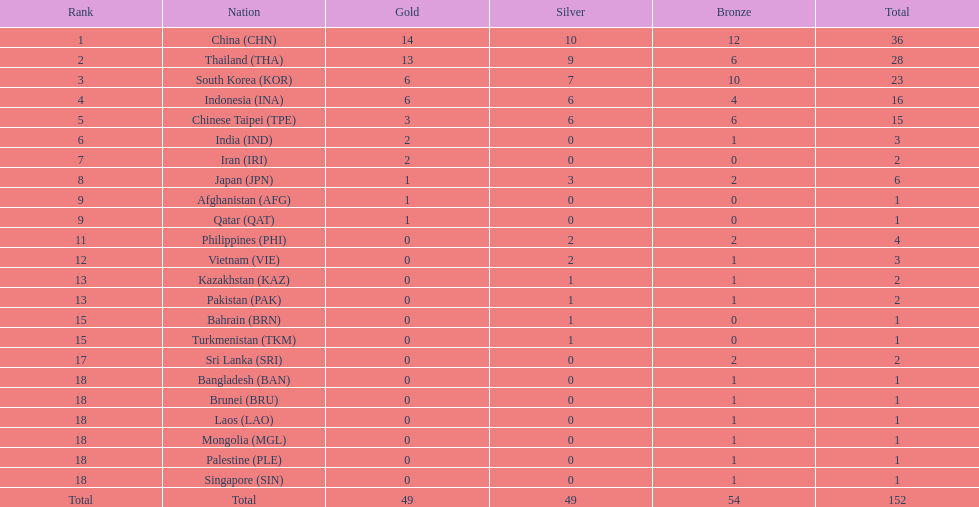Could you help me parse every detail presented in this table? {'header': ['Rank', 'Nation', 'Gold', 'Silver', 'Bronze', 'Total'], 'rows': [['1', 'China\xa0(CHN)', '14', '10', '12', '36'], ['2', 'Thailand\xa0(THA)', '13', '9', '6', '28'], ['3', 'South Korea\xa0(KOR)', '6', '7', '10', '23'], ['4', 'Indonesia\xa0(INA)', '6', '6', '4', '16'], ['5', 'Chinese Taipei\xa0(TPE)', '3', '6', '6', '15'], ['6', 'India\xa0(IND)', '2', '0', '1', '3'], ['7', 'Iran\xa0(IRI)', '2', '0', '0', '2'], ['8', 'Japan\xa0(JPN)', '1', '3', '2', '6'], ['9', 'Afghanistan\xa0(AFG)', '1', '0', '0', '1'], ['9', 'Qatar\xa0(QAT)', '1', '0', '0', '1'], ['11', 'Philippines\xa0(PHI)', '0', '2', '2', '4'], ['12', 'Vietnam\xa0(VIE)', '0', '2', '1', '3'], ['13', 'Kazakhstan\xa0(KAZ)', '0', '1', '1', '2'], ['13', 'Pakistan\xa0(PAK)', '0', '1', '1', '2'], ['15', 'Bahrain\xa0(BRN)', '0', '1', '0', '1'], ['15', 'Turkmenistan\xa0(TKM)', '0', '1', '0', '1'], ['17', 'Sri Lanka\xa0(SRI)', '0', '0', '2', '2'], ['18', 'Bangladesh\xa0(BAN)', '0', '0', '1', '1'], ['18', 'Brunei\xa0(BRU)', '0', '0', '1', '1'], ['18', 'Laos\xa0(LAO)', '0', '0', '1', '1'], ['18', 'Mongolia\xa0(MGL)', '0', '0', '1', '1'], ['18', 'Palestine\xa0(PLE)', '0', '0', '1', '1'], ['18', 'Singapore\xa0(SIN)', '0', '0', '1', '1'], ['Total', 'Total', '49', '49', '54', '152']]} How many additional medals did india obtain in comparison to pakistan? 1. 